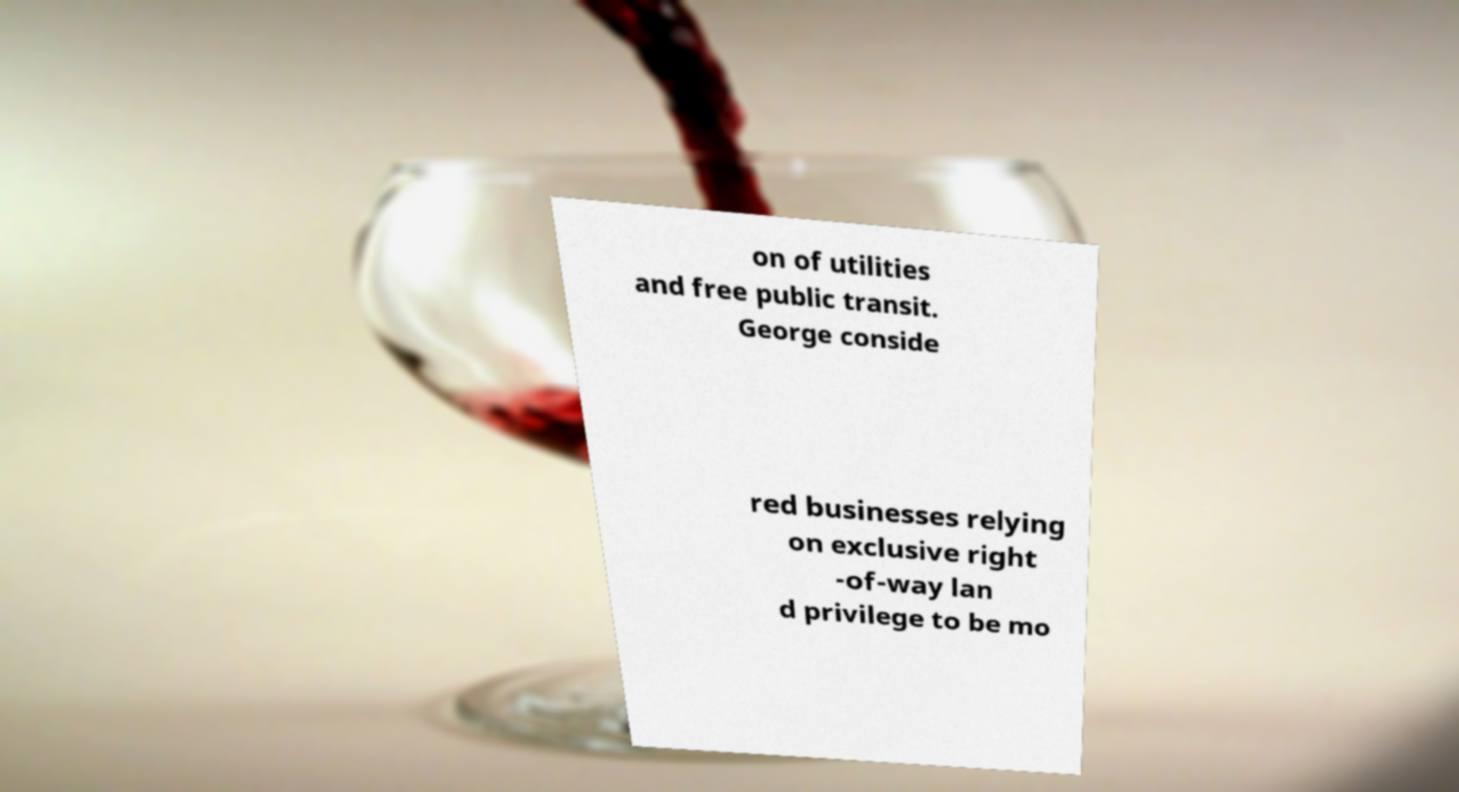I need the written content from this picture converted into text. Can you do that? on of utilities and free public transit. George conside red businesses relying on exclusive right -of-way lan d privilege to be mo 